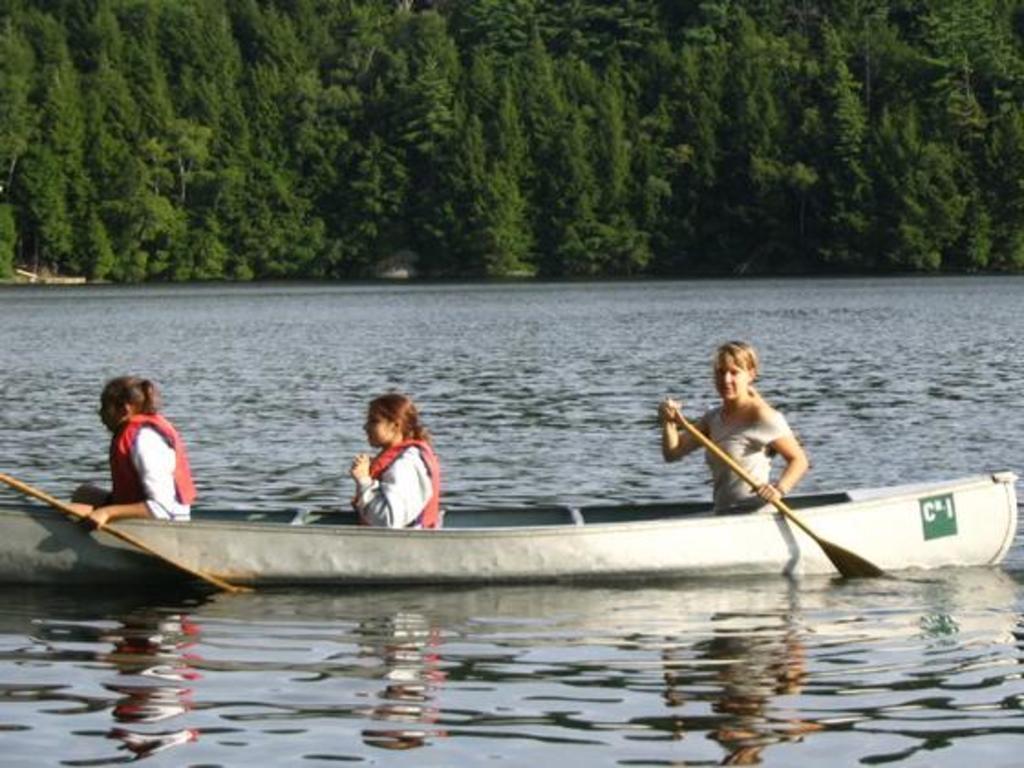Describe this image in one or two sentences. In the image there are three women sitting on a ship in a lake, in the back there are trees all over the image. 